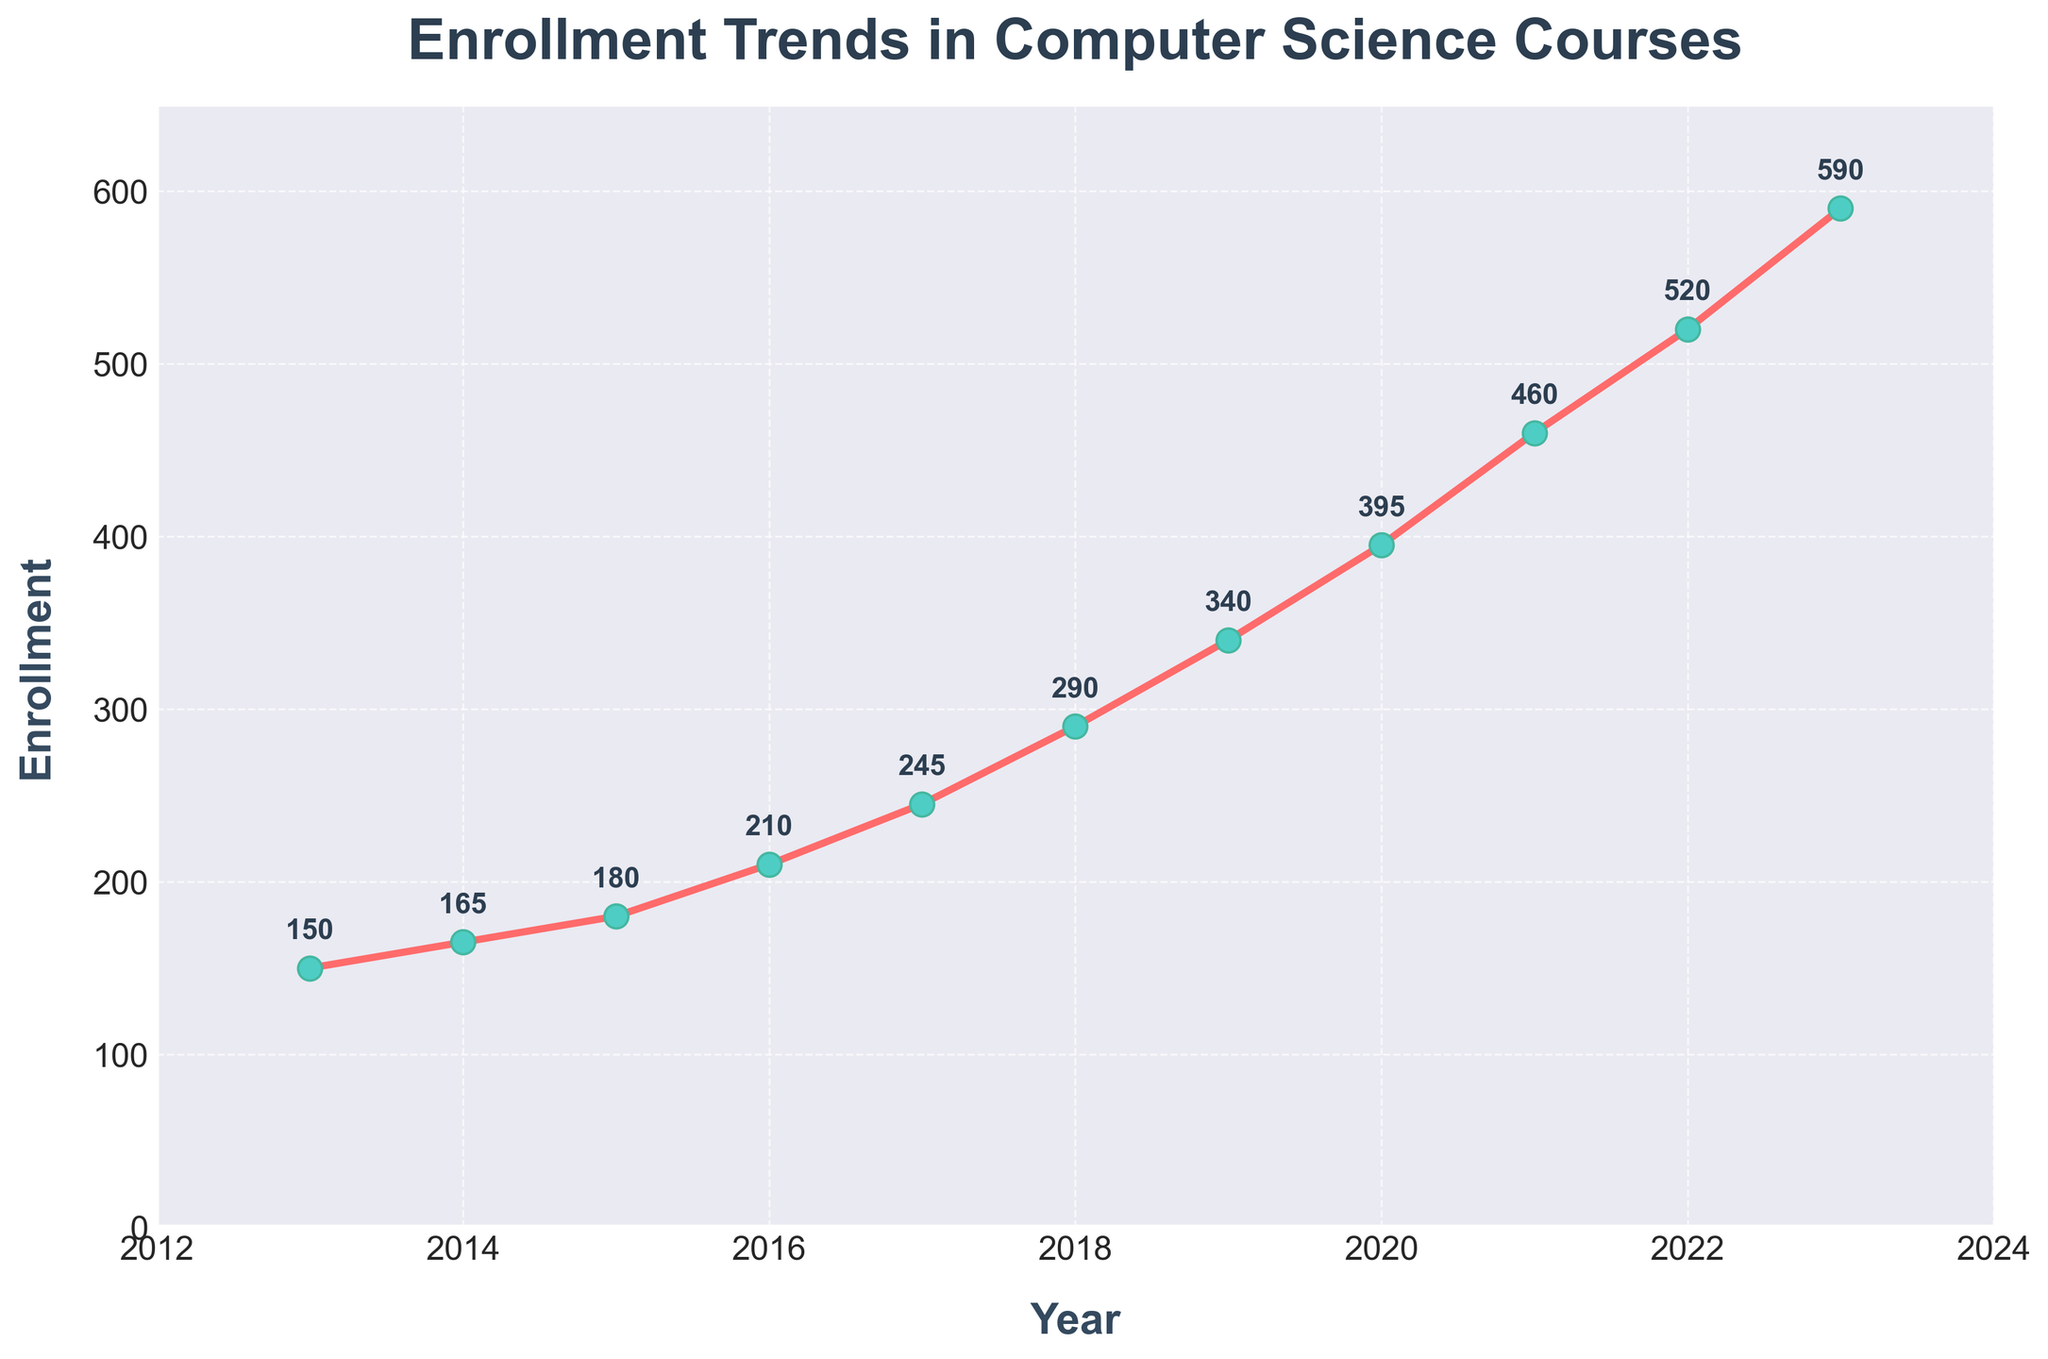What's the average yearly enrollment over the last decade? To find the average yearly enrollment, sum all the enrollment values and divide by the number of years (11). The sum is 150 + 165 + 180 + 210 + 245 + 290 + 340 + 395 + 460 + 520 + 590 = 3555. Therefore, the average is 3555 / 11 ≈ 323.2
Answer: 323.2 Between which two consecutive years did the enrollment increase the most? To determine the largest increase, calculate the differences between consecutive years and identify the maximum one. Differences: 15 (2013-2014), 15 (2014-2015), 30 (2015-2016), 35 (2016-2017), 45 (2017-2018), 50 (2018-2019), 55 (2019-2020), 65 (2020-2021), 60 (2021-2022), 70 (2022-2023). The largest increase is 70 from 2022 to 2023
Answer: 2022 to 2023 What is the overall trend of the enrollment from 2013 to 2023? By observing the plotted line, it is evident that enrollment has been consistently increasing each year, indicating a positive and upward trend
Answer: Increasing How does the enrollment in 2023 compare to that in 2013? The enrollment in 2023 is 590, while in 2013 it was 150. The enrollment has increased by 590 - 150 = 440
Answer: 440 In which year did the enrollment first exceed 300 students? By examining the annotations for each data point, the first year where enrollment exceeded 300 was 2017 with 340 students
Answer: 2019 What's the percentage increase in enrollment from 2016 to 2023? Calculate the enrollment change from 2016 (210) to 2023 (590), and then find the percentage: (590 - 210) / 210 * 100 ≈ 180.95%
Answer: ~180.95% By how much did the enrollment increase between 2018 and 2019? Subtract the enrollment in 2018 from that in 2019: 340 - 290 = 50
Answer: 50 Is there any year when the enrollment decreased compared to the previous year? Based on the plotted line and data values, no year shows a decrease in enrollment; it increases every year
Answer: No How many years did it take for the enrollment to double from 150? Determine the next occurrence of double (150 * 2 = 300) after 2013. This happens in 2018 when enrollment reached 290. It fully doubled in 2019 with 340 enrollments. So, from 2013 to 2019: 2019 - 2013 = 6 years
Answer: 6 Which year had the highest enrollment and what was the value? From the plot, the highest enrollment is in 2023, with a value of 590
Answer: 2023, 590 